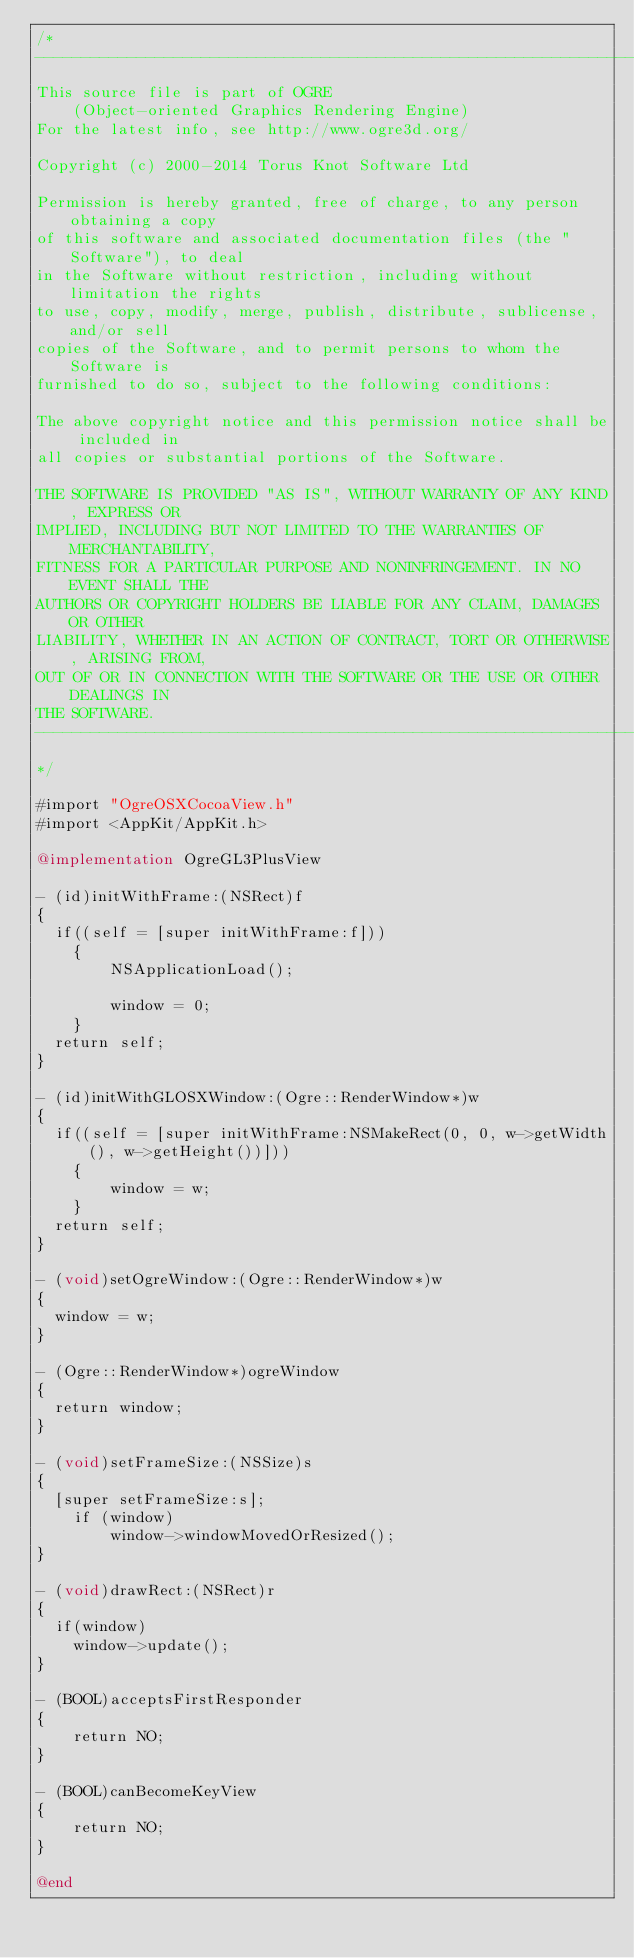<code> <loc_0><loc_0><loc_500><loc_500><_ObjectiveC_>/*
-----------------------------------------------------------------------------
This source file is part of OGRE
    (Object-oriented Graphics Rendering Engine)
For the latest info, see http://www.ogre3d.org/

Copyright (c) 2000-2014 Torus Knot Software Ltd

Permission is hereby granted, free of charge, to any person obtaining a copy
of this software and associated documentation files (the "Software"), to deal
in the Software without restriction, including without limitation the rights
to use, copy, modify, merge, publish, distribute, sublicense, and/or sell
copies of the Software, and to permit persons to whom the Software is
furnished to do so, subject to the following conditions:

The above copyright notice and this permission notice shall be included in
all copies or substantial portions of the Software.

THE SOFTWARE IS PROVIDED "AS IS", WITHOUT WARRANTY OF ANY KIND, EXPRESS OR
IMPLIED, INCLUDING BUT NOT LIMITED TO THE WARRANTIES OF MERCHANTABILITY,
FITNESS FOR A PARTICULAR PURPOSE AND NONINFRINGEMENT. IN NO EVENT SHALL THE
AUTHORS OR COPYRIGHT HOLDERS BE LIABLE FOR ANY CLAIM, DAMAGES OR OTHER
LIABILITY, WHETHER IN AN ACTION OF CONTRACT, TORT OR OTHERWISE, ARISING FROM,
OUT OF OR IN CONNECTION WITH THE SOFTWARE OR THE USE OR OTHER DEALINGS IN
THE SOFTWARE.
-----------------------------------------------------------------------------
*/

#import "OgreOSXCocoaView.h"
#import <AppKit/AppKit.h>

@implementation OgreGL3PlusView

- (id)initWithFrame:(NSRect)f
{
	if((self = [super initWithFrame:f]))
    {
        NSApplicationLoad();
        
        window = 0;
    }
	return self;
}

- (id)initWithGLOSXWindow:(Ogre::RenderWindow*)w
{
	if((self = [super initWithFrame:NSMakeRect(0, 0, w->getWidth(), w->getHeight())]))
    {
        window = w;
    }
	return self;
}

- (void)setOgreWindow:(Ogre::RenderWindow*)w
{
	window = w;
}

- (Ogre::RenderWindow*)ogreWindow
{
	return window;
}

- (void)setFrameSize:(NSSize)s
{
	[super setFrameSize:s];
    if (window)
        window->windowMovedOrResized();
}

- (void)drawRect:(NSRect)r
{
	if(window)
		window->update();
}

- (BOOL)acceptsFirstResponder
{
    return NO;
}

- (BOOL)canBecomeKeyView
{
    return NO;
}

@end
</code> 